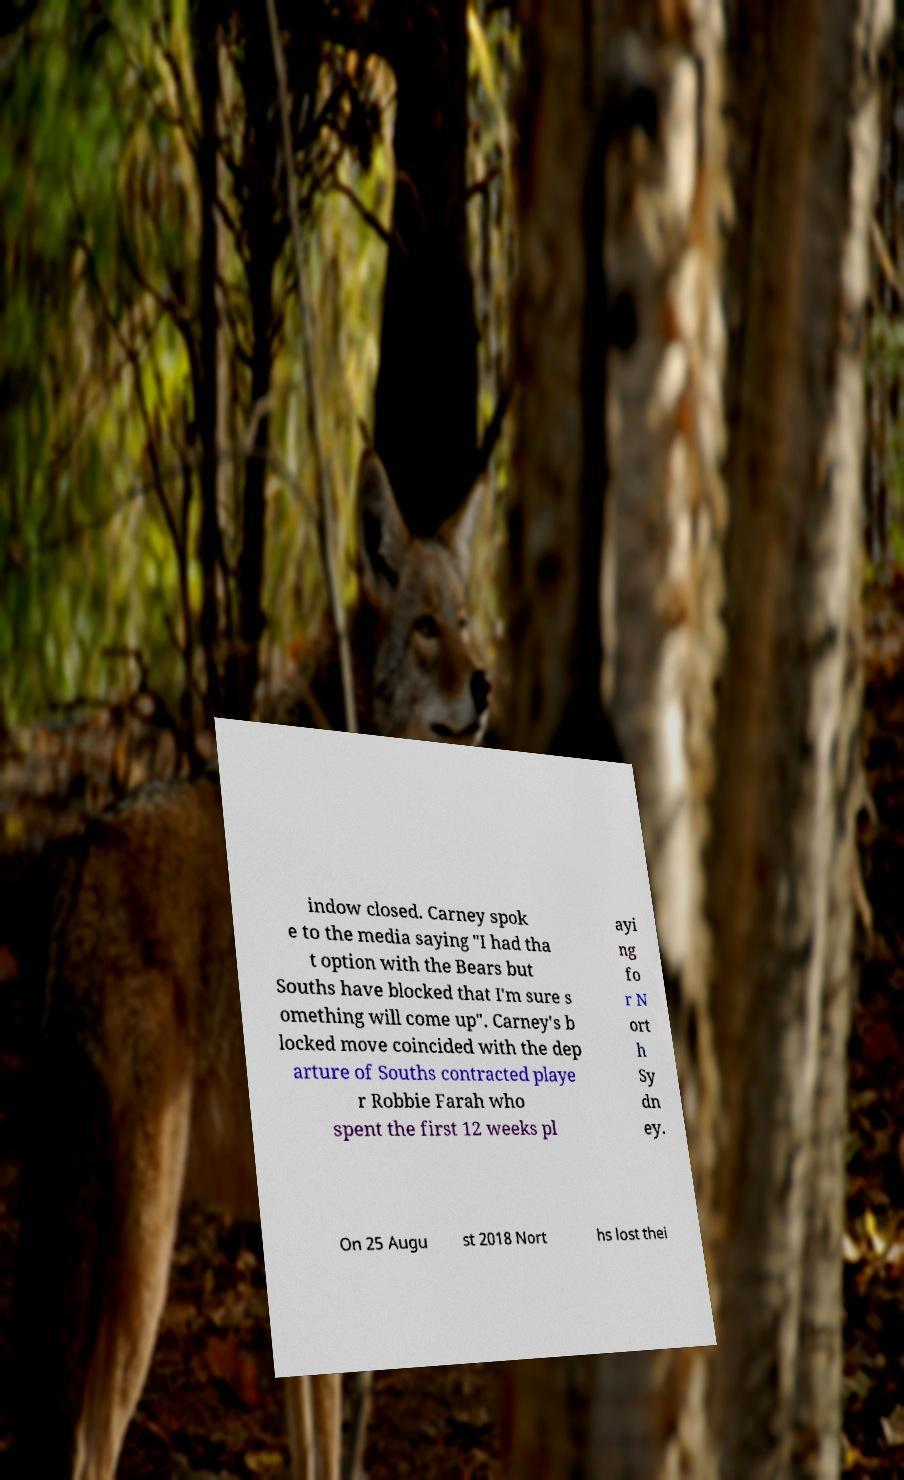Please read and relay the text visible in this image. What does it say? indow closed. Carney spok e to the media saying "I had tha t option with the Bears but Souths have blocked that I'm sure s omething will come up". Carney's b locked move coincided with the dep arture of Souths contracted playe r Robbie Farah who spent the first 12 weeks pl ayi ng fo r N ort h Sy dn ey. On 25 Augu st 2018 Nort hs lost thei 